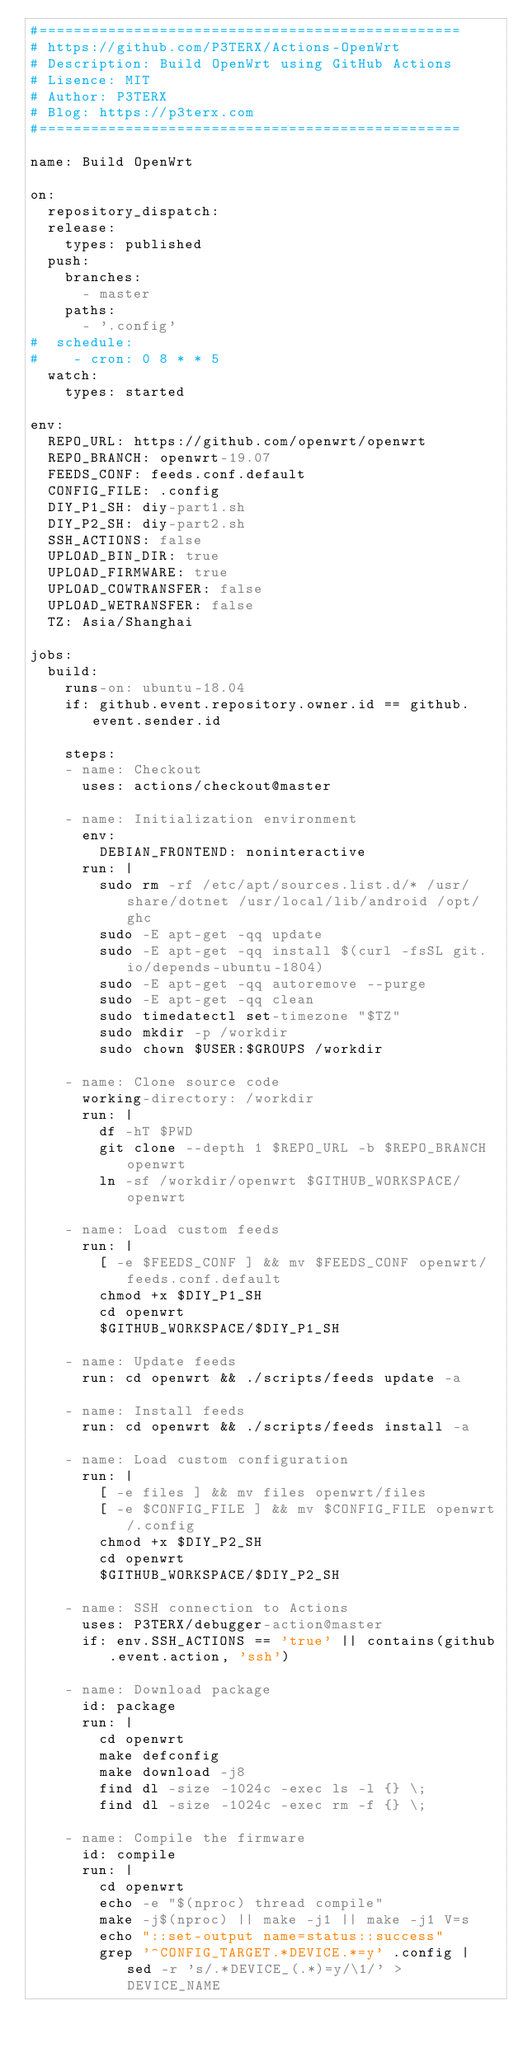<code> <loc_0><loc_0><loc_500><loc_500><_YAML_>#=================================================
# https://github.com/P3TERX/Actions-OpenWrt
# Description: Build OpenWrt using GitHub Actions
# Lisence: MIT
# Author: P3TERX
# Blog: https://p3terx.com
#=================================================

name: Build OpenWrt

on:
  repository_dispatch:
  release:
    types: published
  push:
    branches:
      - master
    paths:
      - '.config'
#  schedule:
#    - cron: 0 8 * * 5
  watch:
    types: started

env:
  REPO_URL: https://github.com/openwrt/openwrt
  REPO_BRANCH: openwrt-19.07
  FEEDS_CONF: feeds.conf.default
  CONFIG_FILE: .config
  DIY_P1_SH: diy-part1.sh
  DIY_P2_SH: diy-part2.sh
  SSH_ACTIONS: false
  UPLOAD_BIN_DIR: true
  UPLOAD_FIRMWARE: true
  UPLOAD_COWTRANSFER: false
  UPLOAD_WETRANSFER: false
  TZ: Asia/Shanghai

jobs:
  build:
    runs-on: ubuntu-18.04
    if: github.event.repository.owner.id == github.event.sender.id

    steps:
    - name: Checkout
      uses: actions/checkout@master

    - name: Initialization environment
      env:
        DEBIAN_FRONTEND: noninteractive
      run: |
        sudo rm -rf /etc/apt/sources.list.d/* /usr/share/dotnet /usr/local/lib/android /opt/ghc
        sudo -E apt-get -qq update
        sudo -E apt-get -qq install $(curl -fsSL git.io/depends-ubuntu-1804)
        sudo -E apt-get -qq autoremove --purge
        sudo -E apt-get -qq clean
        sudo timedatectl set-timezone "$TZ"
        sudo mkdir -p /workdir
        sudo chown $USER:$GROUPS /workdir

    - name: Clone source code
      working-directory: /workdir
      run: |
        df -hT $PWD
        git clone --depth 1 $REPO_URL -b $REPO_BRANCH openwrt
        ln -sf /workdir/openwrt $GITHUB_WORKSPACE/openwrt

    - name: Load custom feeds
      run: |
        [ -e $FEEDS_CONF ] && mv $FEEDS_CONF openwrt/feeds.conf.default
        chmod +x $DIY_P1_SH
        cd openwrt
        $GITHUB_WORKSPACE/$DIY_P1_SH

    - name: Update feeds
      run: cd openwrt && ./scripts/feeds update -a

    - name: Install feeds
      run: cd openwrt && ./scripts/feeds install -a

    - name: Load custom configuration
      run: |
        [ -e files ] && mv files openwrt/files
        [ -e $CONFIG_FILE ] && mv $CONFIG_FILE openwrt/.config
        chmod +x $DIY_P2_SH
        cd openwrt
        $GITHUB_WORKSPACE/$DIY_P2_SH

    - name: SSH connection to Actions
      uses: P3TERX/debugger-action@master
      if: env.SSH_ACTIONS == 'true' || contains(github.event.action, 'ssh')

    - name: Download package
      id: package
      run: |
        cd openwrt
        make defconfig
        make download -j8
        find dl -size -1024c -exec ls -l {} \;
        find dl -size -1024c -exec rm -f {} \;

    - name: Compile the firmware
      id: compile
      run: |
        cd openwrt
        echo -e "$(nproc) thread compile"
        make -j$(nproc) || make -j1 || make -j1 V=s
        echo "::set-output name=status::success"
        grep '^CONFIG_TARGET.*DEVICE.*=y' .config | sed -r 's/.*DEVICE_(.*)=y/\1/' > DEVICE_NAME</code> 